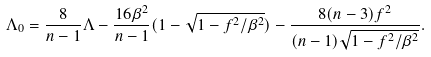Convert formula to latex. <formula><loc_0><loc_0><loc_500><loc_500>\Lambda _ { 0 } = \frac { 8 } { n - 1 } \Lambda - \frac { 1 6 \beta ^ { 2 } } { n - 1 } ( 1 - \sqrt { 1 - f ^ { 2 } / \beta ^ { 2 } } ) - \frac { 8 ( n - 3 ) f ^ { 2 } } { ( n - 1 ) \sqrt { 1 - f ^ { 2 } / \beta ^ { 2 } } } .</formula> 